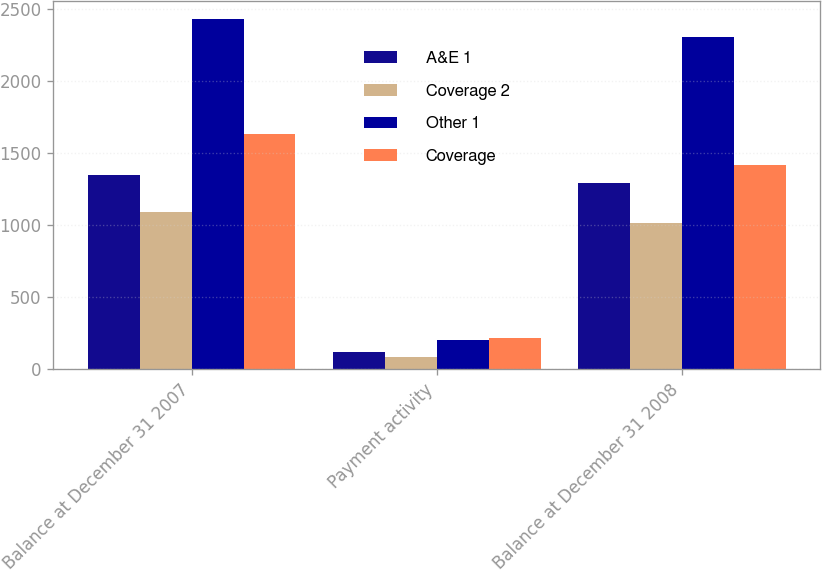<chart> <loc_0><loc_0><loc_500><loc_500><stacked_bar_chart><ecel><fcel>Balance at December 31 2007<fcel>Payment activity<fcel>Balance at December 31 2008<nl><fcel>A&E 1<fcel>1344<fcel>115<fcel>1290<nl><fcel>Coverage 2<fcel>1089<fcel>83<fcel>1012<nl><fcel>Other 1<fcel>2433<fcel>198<fcel>2302<nl><fcel>Coverage<fcel>1630<fcel>213<fcel>1417<nl></chart> 